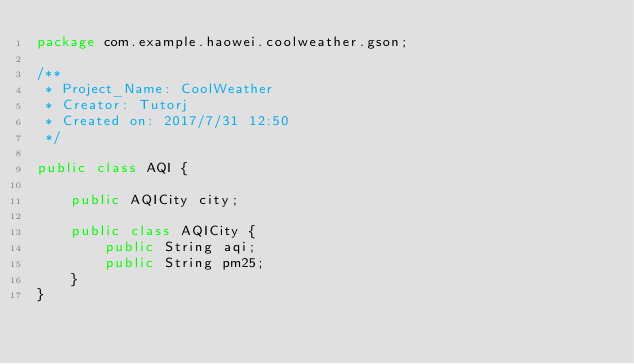<code> <loc_0><loc_0><loc_500><loc_500><_Java_>package com.example.haowei.coolweather.gson;

/**
 * Project_Name: CoolWeather
 * Creator: Tutorj
 * Created on: 2017/7/31 12:50
 */

public class AQI {

    public AQICity city;

    public class AQICity {
        public String aqi;
        public String pm25;
    }
}
</code> 